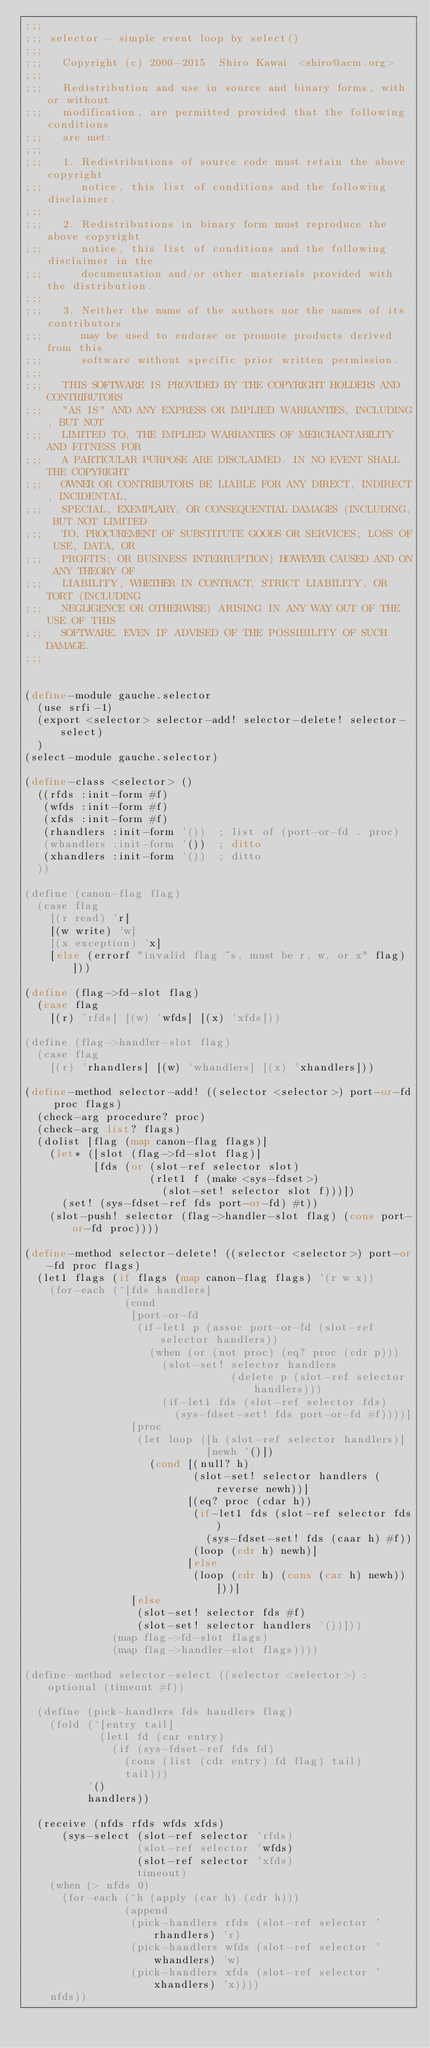Convert code to text. <code><loc_0><loc_0><loc_500><loc_500><_Scheme_>;;;
;;; selector - simple event loop by select()
;;;
;;;   Copyright (c) 2000-2015  Shiro Kawai  <shiro@acm.org>
;;;
;;;   Redistribution and use in source and binary forms, with or without
;;;   modification, are permitted provided that the following conditions
;;;   are met:
;;;
;;;   1. Redistributions of source code must retain the above copyright
;;;      notice, this list of conditions and the following disclaimer.
;;;
;;;   2. Redistributions in binary form must reproduce the above copyright
;;;      notice, this list of conditions and the following disclaimer in the
;;;      documentation and/or other materials provided with the distribution.
;;;
;;;   3. Neither the name of the authors nor the names of its contributors
;;;      may be used to endorse or promote products derived from this
;;;      software without specific prior written permission.
;;;
;;;   THIS SOFTWARE IS PROVIDED BY THE COPYRIGHT HOLDERS AND CONTRIBUTORS
;;;   "AS IS" AND ANY EXPRESS OR IMPLIED WARRANTIES, INCLUDING, BUT NOT
;;;   LIMITED TO, THE IMPLIED WARRANTIES OF MERCHANTABILITY AND FITNESS FOR
;;;   A PARTICULAR PURPOSE ARE DISCLAIMED. IN NO EVENT SHALL THE COPYRIGHT
;;;   OWNER OR CONTRIBUTORS BE LIABLE FOR ANY DIRECT, INDIRECT, INCIDENTAL,
;;;   SPECIAL, EXEMPLARY, OR CONSEQUENTIAL DAMAGES (INCLUDING, BUT NOT LIMITED
;;;   TO, PROCUREMENT OF SUBSTITUTE GOODS OR SERVICES; LOSS OF USE, DATA, OR
;;;   PROFITS; OR BUSINESS INTERRUPTION) HOWEVER CAUSED AND ON ANY THEORY OF
;;;   LIABILITY, WHETHER IN CONTRACT, STRICT LIABILITY, OR TORT (INCLUDING
;;;   NEGLIGENCE OR OTHERWISE) ARISING IN ANY WAY OUT OF THE USE OF THIS
;;;   SOFTWARE, EVEN IF ADVISED OF THE POSSIBILITY OF SUCH DAMAGE.
;;;


(define-module gauche.selector
  (use srfi-1)
  (export <selector> selector-add! selector-delete! selector-select)
  )
(select-module gauche.selector)

(define-class <selector> ()
  ((rfds :init-form #f)
   (wfds :init-form #f)
   (xfds :init-form #f)
   (rhandlers :init-form '())  ; list of (port-or-fd . proc)
   (whandlers :init-form '())  ; ditto
   (xhandlers :init-form '())  ; ditto
  ))

(define (canon-flag flag)
  (case flag
    [(r read) 'r]
    [(w write) 'w]
    [(x exception) 'x]
    [else (errorf "invalid flag ~s, must be r, w, or x" flag)]))

(define (flag->fd-slot flag)
  (case flag
    [(r) 'rfds] [(w) 'wfds] [(x) 'xfds]))

(define (flag->handler-slot flag)
  (case flag
    [(r) 'rhandlers] [(w) 'whandlers] [(x) 'xhandlers]))

(define-method selector-add! ((selector <selector>) port-or-fd proc flags)
  (check-arg procedure? proc)
  (check-arg list? flags)
  (dolist [flag (map canon-flag flags)]
    (let* ([slot (flag->fd-slot flag)]
           [fds (or (slot-ref selector slot)
                    (rlet1 f (make <sys-fdset>)
                      (slot-set! selector slot f)))])
      (set! (sys-fdset-ref fds port-or-fd) #t))
    (slot-push! selector (flag->handler-slot flag) (cons port-or-fd proc))))

(define-method selector-delete! ((selector <selector>) port-or-fd proc flags)
  (let1 flags (if flags (map canon-flag flags) '(r w x))
    (for-each (^[fds handlers]
                (cond
                 [port-or-fd
                  (if-let1 p (assoc port-or-fd (slot-ref selector handlers))
                    (when (or (not proc) (eq? proc (cdr p)))
                      (slot-set! selector handlers
                                 (delete p (slot-ref selector handlers)))
                      (if-let1 fds (slot-ref selector fds)
                        (sys-fdset-set! fds port-or-fd #f))))]
                 [proc
                  (let loop ([h (slot-ref selector handlers)]
                             [newh '()])
                    (cond [(null? h)
                           (slot-set! selector handlers (reverse newh))]
                          [(eq? proc (cdar h))
                           (if-let1 fds (slot-ref selector fds)
                             (sys-fdset-set! fds (caar h) #f))
                           (loop (cdr h) newh)]
                          [else
                           (loop (cdr h) (cons (car h) newh))]))]
                 [else
                  (slot-set! selector fds #f)
                  (slot-set! selector handlers '())]))
              (map flag->fd-slot flags)
              (map flag->handler-slot flags))))

(define-method selector-select ((selector <selector>) :optional (timeout #f))

  (define (pick-handlers fds handlers flag)
    (fold (^[entry tail]
            (let1 fd (car entry)
              (if (sys-fdset-ref fds fd)
                (cons (list (cdr entry) fd flag) tail)
                tail)))
          '()
          handlers))

  (receive (nfds rfds wfds xfds)
      (sys-select (slot-ref selector 'rfds)
                  (slot-ref selector 'wfds)
                  (slot-ref selector 'xfds)
                  timeout)
    (when (> nfds 0)
      (for-each (^h (apply (car h) (cdr h)))
                (append
                 (pick-handlers rfds (slot-ref selector 'rhandlers) 'r)
                 (pick-handlers wfds (slot-ref selector 'whandlers) 'w)
                 (pick-handlers xfds (slot-ref selector 'xhandlers) 'x))))
    nfds))
</code> 